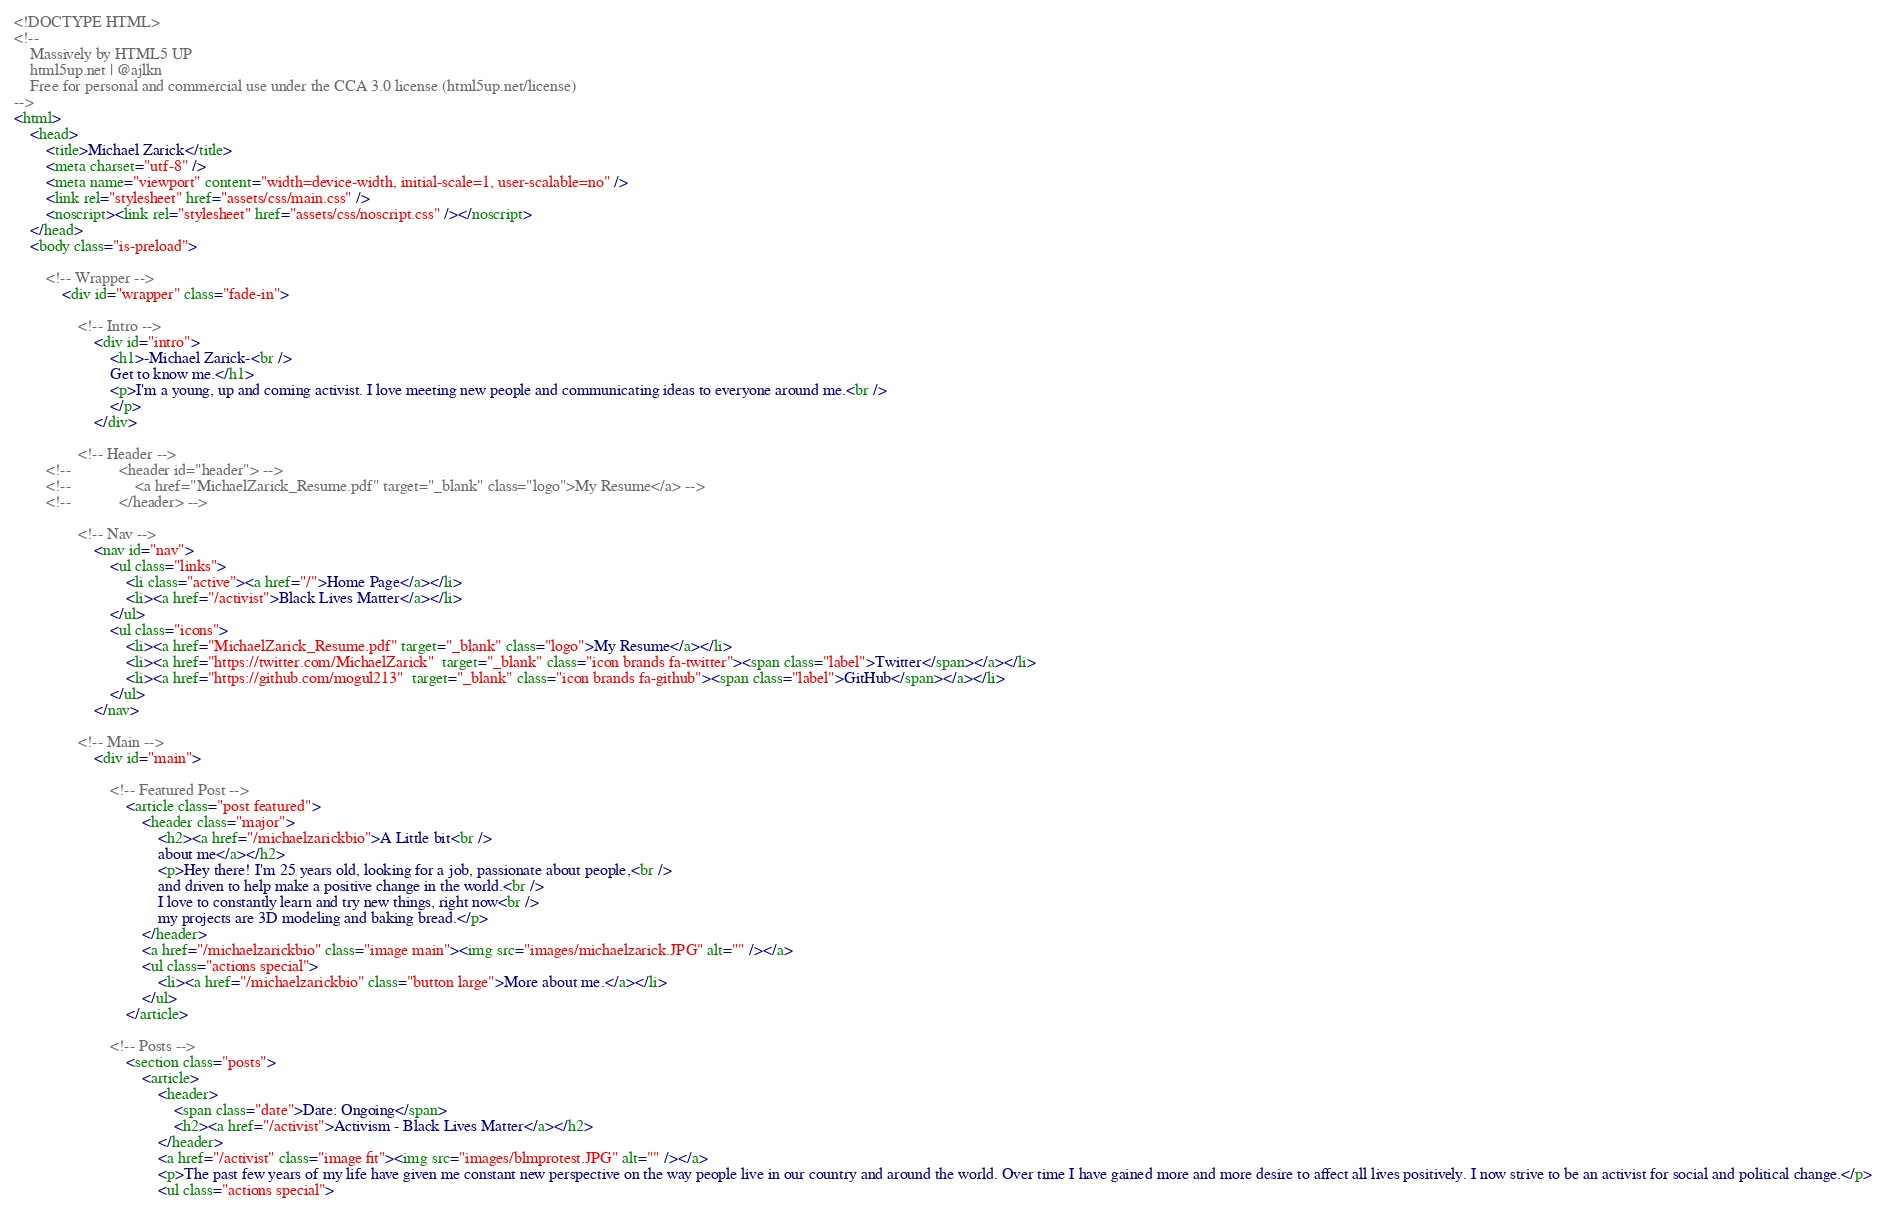<code> <loc_0><loc_0><loc_500><loc_500><_HTML_><!DOCTYPE HTML>
<!--
	Massively by HTML5 UP
	html5up.net | @ajlkn
	Free for personal and commercial use under the CCA 3.0 license (html5up.net/license)
-->
<html>
	<head>
		<title>Michael Zarick</title>
		<meta charset="utf-8" />
		<meta name="viewport" content="width=device-width, initial-scale=1, user-scalable=no" />
		<link rel="stylesheet" href="assets/css/main.css" />
		<noscript><link rel="stylesheet" href="assets/css/noscript.css" /></noscript>
	</head>
	<body class="is-preload">

		<!-- Wrapper -->
			<div id="wrapper" class="fade-in">

				<!-- Intro -->
					<div id="intro">
						<h1>-Michael Zarick-<br />
						Get to know me.</h1>
						<p>I'm a young, up and coming activist. I love meeting new people and communicating ideas to everyone around me.<br />
						</p>
					</div>

				<!-- Header -->
		<!--			<header id="header"> -->
		<!--				<a href="MichaelZarick_Resume.pdf" target="_blank" class="logo">My Resume</a> -->
		<!--			</header> -->

				<!-- Nav -->
					<nav id="nav">
						<ul class="links"> 
							<li class="active"><a href="/">Home Page</a></li>
							<li><a href="/activist">Black Lives Matter</a></li>
						</ul>
						<ul class="icons">
							<li><a href="MichaelZarick_Resume.pdf" target="_blank" class="logo">My Resume</a></li>
							<li><a href="https://twitter.com/MichaelZarick"  target="_blank" class="icon brands fa-twitter"><span class="label">Twitter</span></a></li>
							<li><a href="https://github.com/mogul213"  target="_blank" class="icon brands fa-github"><span class="label">GitHub</span></a></li>
						</ul>
					</nav>

				<!-- Main -->
					<div id="main">

						<!-- Featured Post -->
							<article class="post featured">
								<header class="major">
									<h2><a href="/michaelzarickbio">A Little bit<br />
									about me</a></h2>
									<p>Hey there! I'm 25 years old, looking for a job, passionate about people,<br />
									and driven to help make a positive change in the world.<br />
									I love to constantly learn and try new things, right now<br />
									my projects are 3D modeling and baking bread.</p>
								</header>
								<a href="/michaelzarickbio" class="image main"><img src="images/michaelzarick.JPG" alt="" /></a>
								<ul class="actions special">
									<li><a href="/michaelzarickbio" class="button large">More about me.</a></li>
								</ul>
							</article>

						<!-- Posts -->
							<section class="posts">
								<article>
									<header>
										<span class="date">Date: Ongoing</span>
										<h2><a href="/activist">Activism - Black Lives Matter</a></h2>
									</header>
									<a href="/activist" class="image fit"><img src="images/blmprotest.JPG" alt="" /></a>
									<p>The past few years of my life have given me constant new perspective on the way people live in our country and around the world. Over time I have gained more and more desire to affect all lives positively. I now strive to be an activist for social and political change.</p>
									<ul class="actions special"></code> 